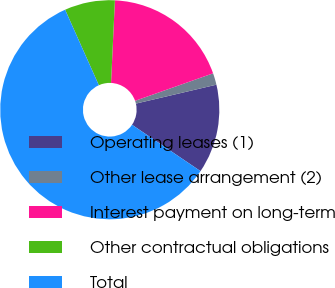<chart> <loc_0><loc_0><loc_500><loc_500><pie_chart><fcel>Operating leases (1)<fcel>Other lease arrangement (2)<fcel>Interest payment on long-term<fcel>Other contractual obligations<fcel>Total<nl><fcel>13.14%<fcel>1.72%<fcel>18.86%<fcel>7.43%<fcel>58.85%<nl></chart> 